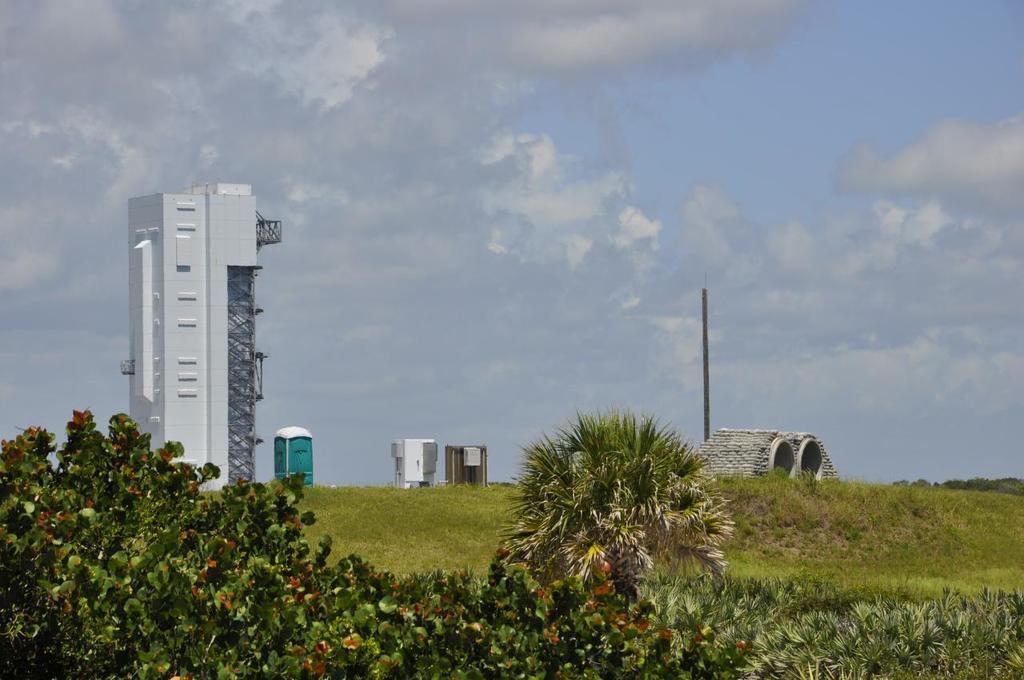In one or two sentences, can you explain what this image depicts? In the foreground of the picture there are trees. In the middle of the picture we can see buildings like tunnels and small rooms and we can see pole and grass. In the background there are clouds in the sky. 